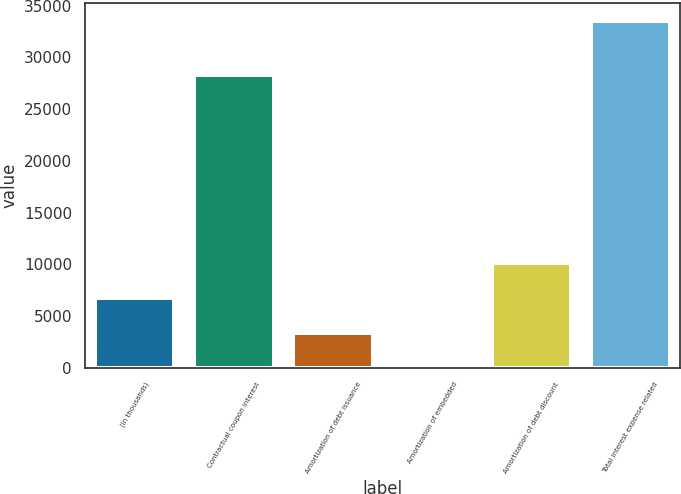<chart> <loc_0><loc_0><loc_500><loc_500><bar_chart><fcel>(In thousands)<fcel>Contractual coupon interest<fcel>Amortization of debt issuance<fcel>Amortization of embedded<fcel>Amortization of debt discount<fcel>Total interest expense related<nl><fcel>6765.2<fcel>28293<fcel>3419.1<fcel>73<fcel>10111.3<fcel>33534<nl></chart> 